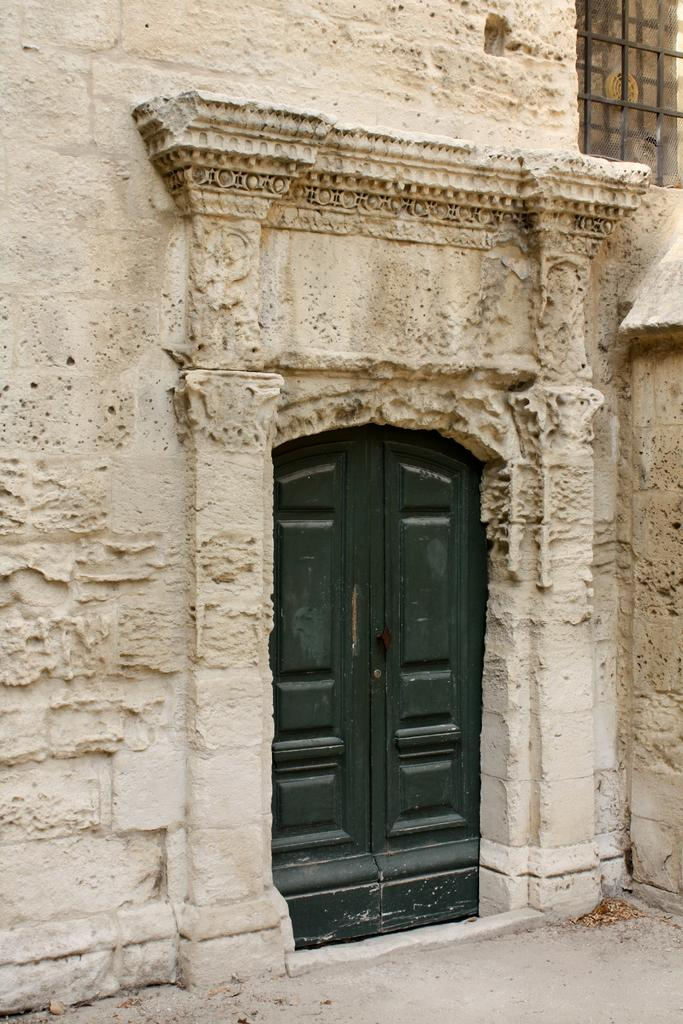What type of structure can be seen in the image? There is a wall in the image. What is a feature that allows access through the wall? There is a door in the image. What is a feature that allows light and air to enter the space? There is a window in the image. How many vehicles are parked in front of the wall in the image? There is no information about any vehicles in the image. What is the temper of the wall in the image? The temper of the wall cannot be determined from the image, as it is an inanimate object. 